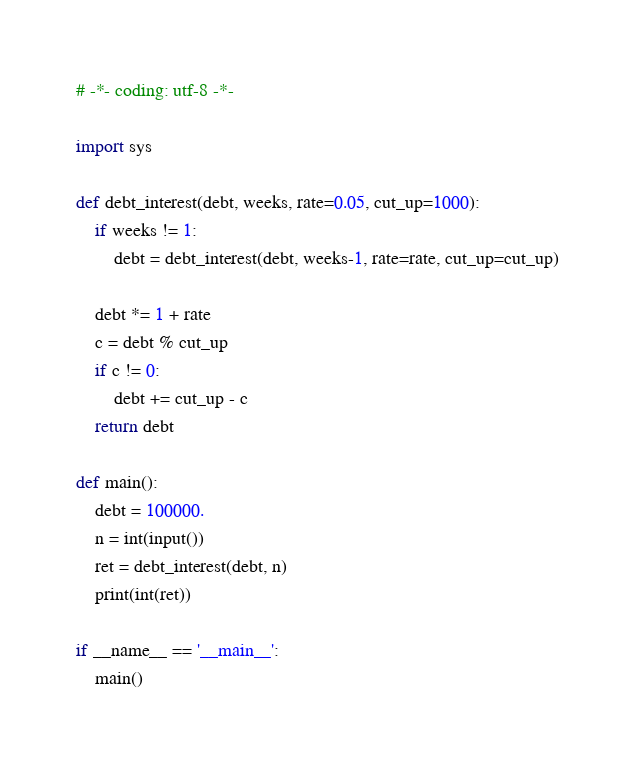Convert code to text. <code><loc_0><loc_0><loc_500><loc_500><_Python_># -*- coding: utf-8 -*-

import sys

def debt_interest(debt, weeks, rate=0.05, cut_up=1000):
    if weeks != 1:
        debt = debt_interest(debt, weeks-1, rate=rate, cut_up=cut_up)

    debt *= 1 + rate
    c = debt % cut_up
    if c != 0:
        debt += cut_up - c
    return debt

def main():
    debt = 100000.
    n = int(input())
    ret = debt_interest(debt, n)
    print(int(ret))

if __name__ == '__main__':
    main()</code> 